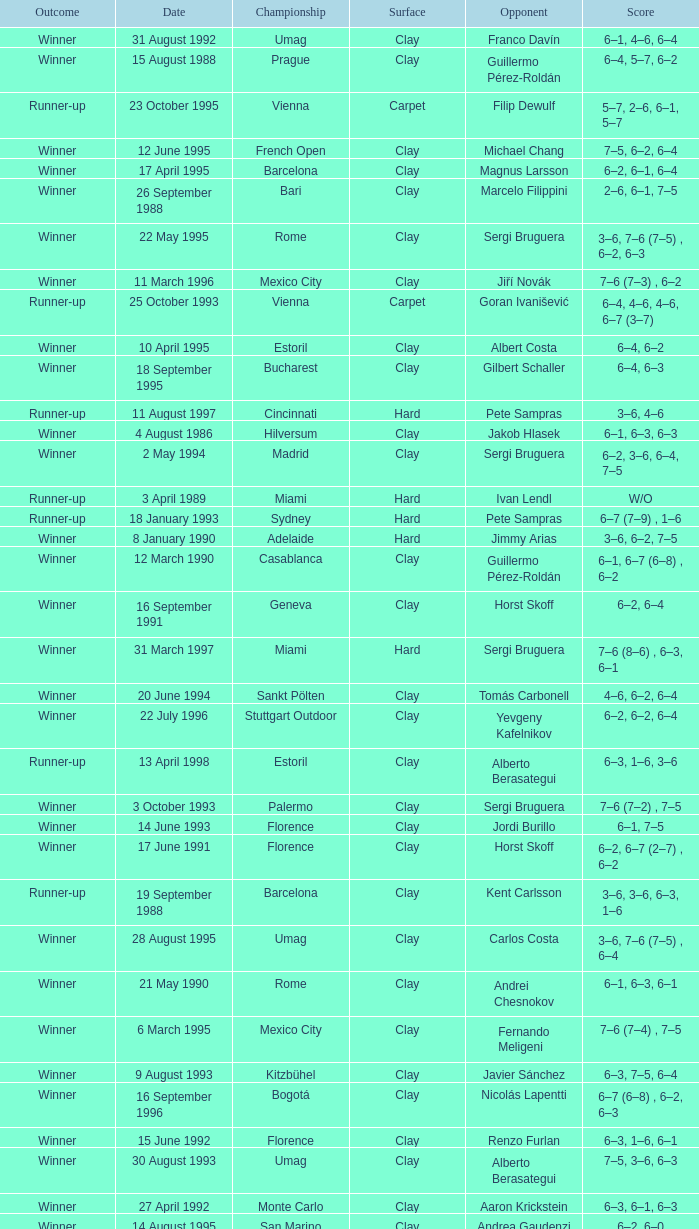Who is the opponent on 18 january 1993? Pete Sampras. 